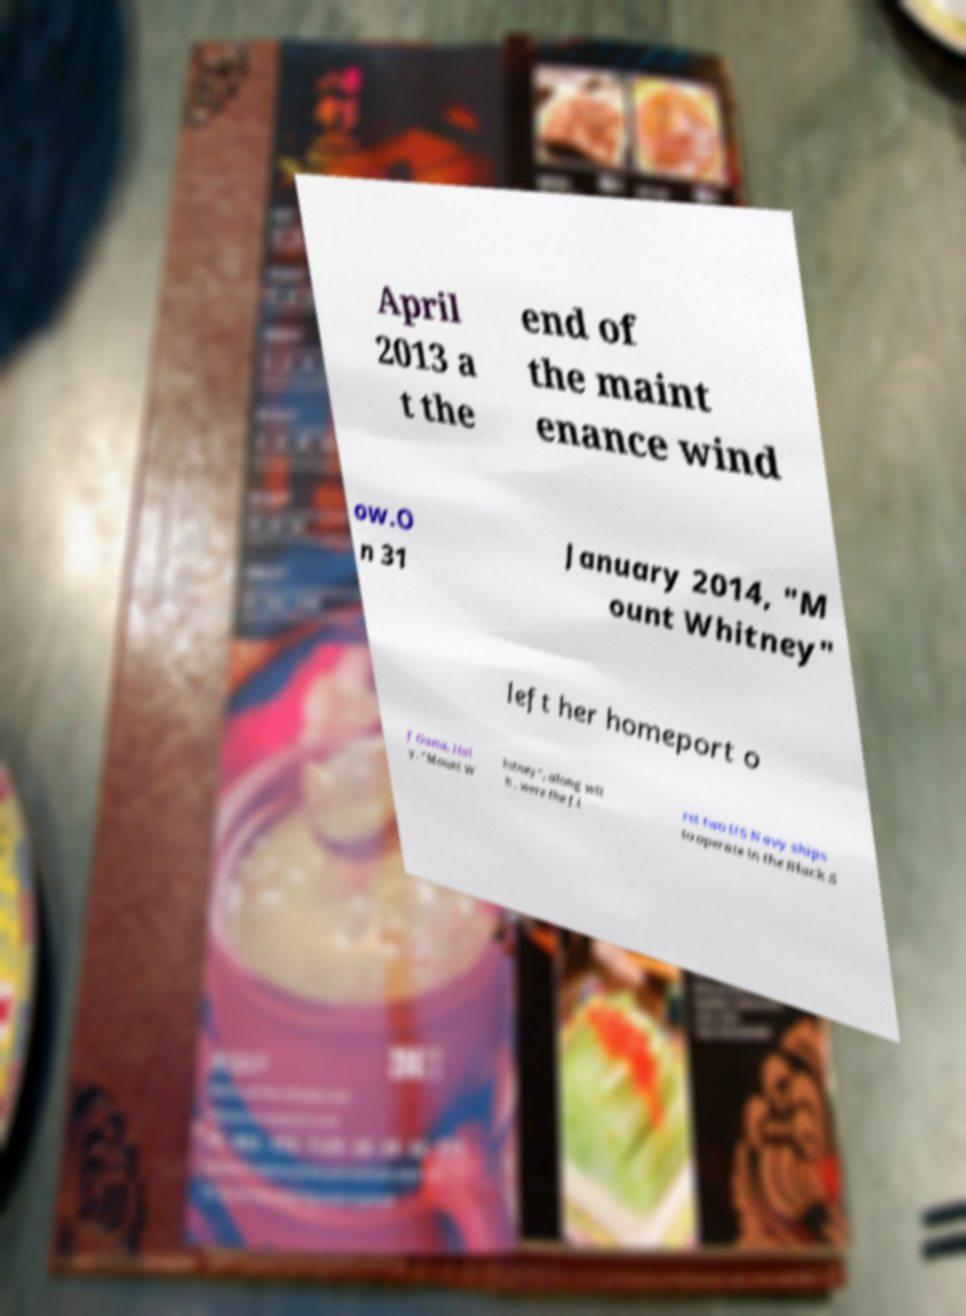There's text embedded in this image that I need extracted. Can you transcribe it verbatim? April 2013 a t the end of the maint enance wind ow.O n 31 January 2014, "M ount Whitney" left her homeport o f Gaeta, Ital y. "Mount W hitney", along wit h , were the fi rst two US Navy ships to operate in the Black S 